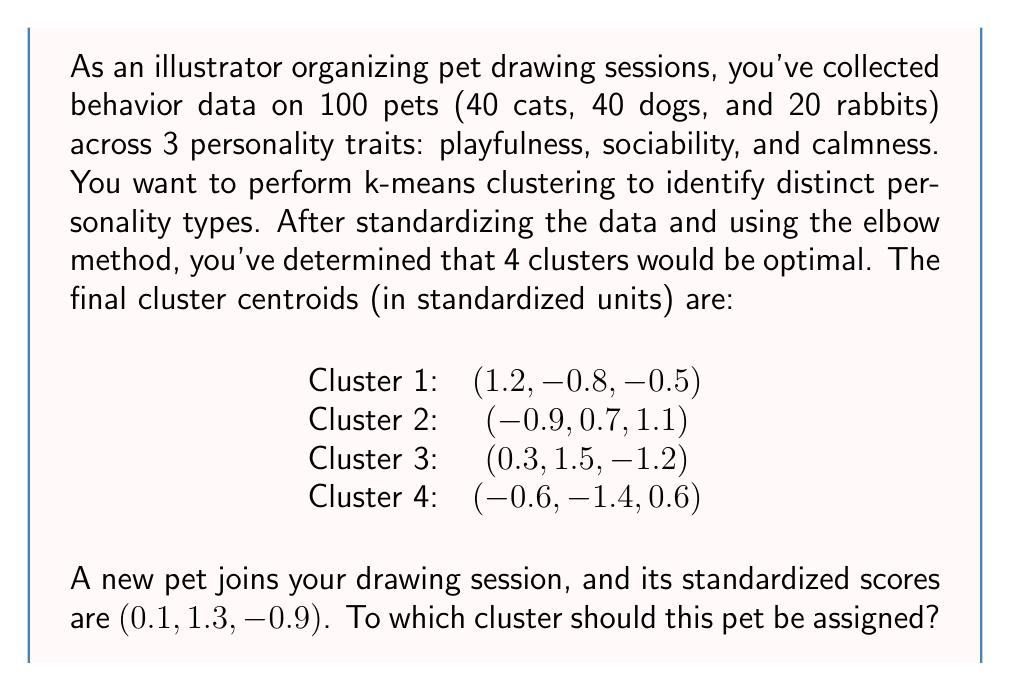Teach me how to tackle this problem. To solve this problem, we need to calculate the Euclidean distance between the new pet's standardized scores and each cluster centroid. The pet should be assigned to the cluster with the smallest distance.

Let's calculate the distance to each cluster:

1. Distance to Cluster 1:
   $$d_1 = \sqrt{(0.1-1.2)^2 + (1.3+0.8)^2 + (-0.9+0.5)^2}$$
   $$d_1 = \sqrt{(-1.1)^2 + (2.1)^2 + (-0.4)^2}$$
   $$d_1 = \sqrt{1.21 + 4.41 + 0.16} = \sqrt{5.78} \approx 2.40$$

2. Distance to Cluster 2:
   $$d_2 = \sqrt{(0.1+0.9)^2 + (1.3-0.7)^2 + (-0.9-1.1)^2}$$
   $$d_2 = \sqrt{(1.0)^2 + (0.6)^2 + (-2.0)^2}$$
   $$d_2 = \sqrt{1.00 + 0.36 + 4.00} = \sqrt{5.36} \approx 2.32$$

3. Distance to Cluster 3:
   $$d_3 = \sqrt{(0.1-0.3)^2 + (1.3-1.5)^2 + (-0.9+1.2)^2}$$
   $$d_3 = \sqrt{(-0.2)^2 + (-0.2)^2 + (0.3)^2}$$
   $$d_3 = \sqrt{0.04 + 0.04 + 0.09} = \sqrt{0.17} \approx 0.41$$

4. Distance to Cluster 4:
   $$d_4 = \sqrt{(0.1+0.6)^2 + (1.3+1.4)^2 + (-0.9-0.6)^2}$$
   $$d_4 = \sqrt{(0.7)^2 + (2.7)^2 + (-1.5)^2}$$
   $$d_4 = \sqrt{0.49 + 7.29 + 2.25} = \sqrt{10.03} \approx 3.17$$

The smallest distance is to Cluster 3 (0.41), so the new pet should be assigned to this cluster.
Answer: Cluster 3 